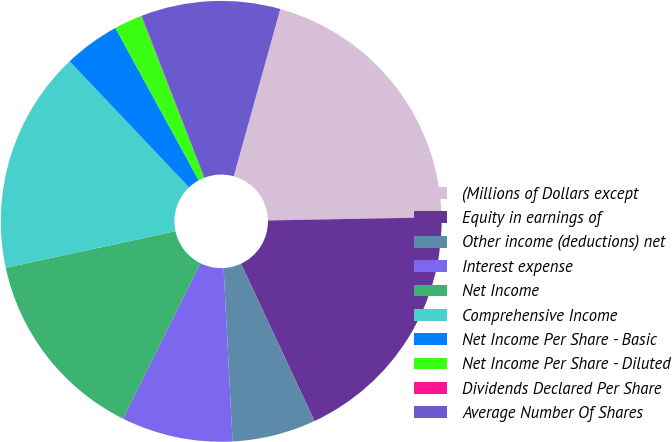Convert chart to OTSL. <chart><loc_0><loc_0><loc_500><loc_500><pie_chart><fcel>(Millions of Dollars except<fcel>Equity in earnings of<fcel>Other income (deductions) net<fcel>Interest expense<fcel>Net Income<fcel>Comprehensive Income<fcel>Net Income Per Share - Basic<fcel>Net Income Per Share - Diluted<fcel>Dividends Declared Per Share<fcel>Average Number Of Shares<nl><fcel>20.38%<fcel>18.34%<fcel>6.13%<fcel>8.17%<fcel>14.27%<fcel>16.31%<fcel>4.1%<fcel>2.06%<fcel>0.03%<fcel>10.2%<nl></chart> 